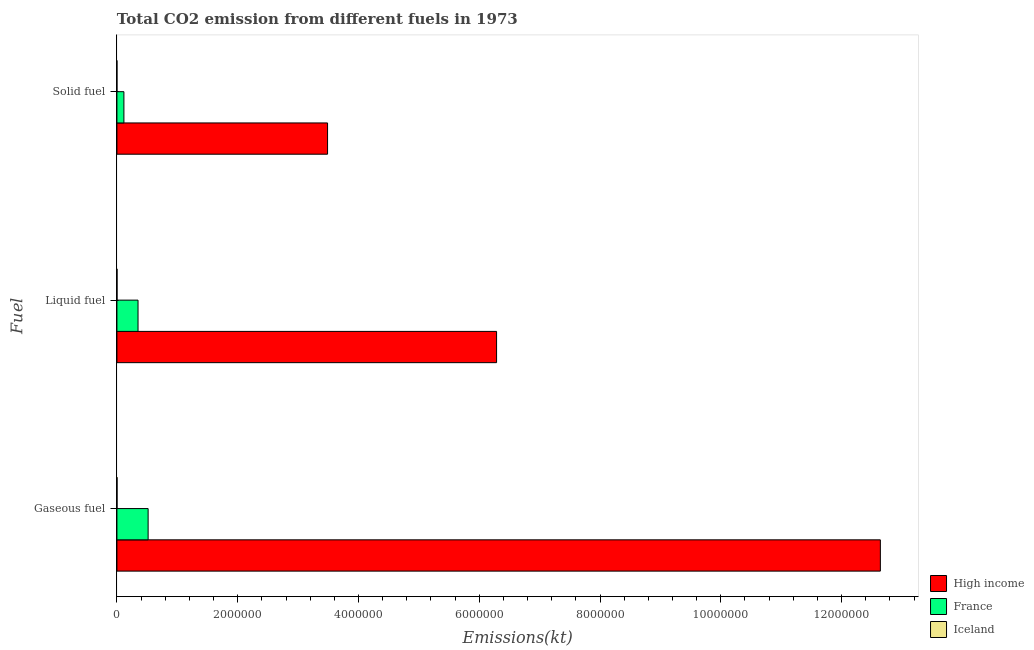How many groups of bars are there?
Offer a very short reply. 3. Are the number of bars on each tick of the Y-axis equal?
Provide a succinct answer. Yes. How many bars are there on the 2nd tick from the bottom?
Ensure brevity in your answer.  3. What is the label of the 3rd group of bars from the top?
Give a very brief answer. Gaseous fuel. What is the amount of co2 emissions from gaseous fuel in High income?
Provide a succinct answer. 1.26e+07. Across all countries, what is the maximum amount of co2 emissions from liquid fuel?
Provide a succinct answer. 6.29e+06. Across all countries, what is the minimum amount of co2 emissions from gaseous fuel?
Ensure brevity in your answer.  1752.83. What is the total amount of co2 emissions from gaseous fuel in the graph?
Your answer should be compact. 1.32e+07. What is the difference between the amount of co2 emissions from gaseous fuel in Iceland and that in France?
Your answer should be compact. -5.15e+05. What is the difference between the amount of co2 emissions from gaseous fuel in France and the amount of co2 emissions from liquid fuel in Iceland?
Your answer should be compact. 5.15e+05. What is the average amount of co2 emissions from liquid fuel per country?
Ensure brevity in your answer.  2.21e+06. What is the difference between the amount of co2 emissions from liquid fuel and amount of co2 emissions from solid fuel in Iceland?
Your answer should be compact. 1683.15. In how many countries, is the amount of co2 emissions from gaseous fuel greater than 1600000 kt?
Keep it short and to the point. 1. What is the ratio of the amount of co2 emissions from gaseous fuel in France to that in Iceland?
Keep it short and to the point. 294.72. What is the difference between the highest and the second highest amount of co2 emissions from gaseous fuel?
Give a very brief answer. 1.21e+07. What is the difference between the highest and the lowest amount of co2 emissions from solid fuel?
Give a very brief answer. 3.49e+06. In how many countries, is the amount of co2 emissions from gaseous fuel greater than the average amount of co2 emissions from gaseous fuel taken over all countries?
Make the answer very short. 1. Is it the case that in every country, the sum of the amount of co2 emissions from gaseous fuel and amount of co2 emissions from liquid fuel is greater than the amount of co2 emissions from solid fuel?
Give a very brief answer. Yes. Where does the legend appear in the graph?
Provide a succinct answer. Bottom right. How are the legend labels stacked?
Offer a very short reply. Vertical. What is the title of the graph?
Your response must be concise. Total CO2 emission from different fuels in 1973. Does "Afghanistan" appear as one of the legend labels in the graph?
Keep it short and to the point. No. What is the label or title of the X-axis?
Ensure brevity in your answer.  Emissions(kt). What is the label or title of the Y-axis?
Your answer should be very brief. Fuel. What is the Emissions(kt) of High income in Gaseous fuel?
Your answer should be very brief. 1.26e+07. What is the Emissions(kt) in France in Gaseous fuel?
Keep it short and to the point. 5.17e+05. What is the Emissions(kt) of Iceland in Gaseous fuel?
Offer a very short reply. 1752.83. What is the Emissions(kt) in High income in Liquid fuel?
Offer a terse response. 6.29e+06. What is the Emissions(kt) in France in Liquid fuel?
Make the answer very short. 3.49e+05. What is the Emissions(kt) in Iceland in Liquid fuel?
Ensure brevity in your answer.  1686.82. What is the Emissions(kt) in High income in Solid fuel?
Your answer should be very brief. 3.49e+06. What is the Emissions(kt) in France in Solid fuel?
Offer a very short reply. 1.16e+05. What is the Emissions(kt) in Iceland in Solid fuel?
Your answer should be compact. 3.67. Across all Fuel, what is the maximum Emissions(kt) in High income?
Provide a short and direct response. 1.26e+07. Across all Fuel, what is the maximum Emissions(kt) of France?
Ensure brevity in your answer.  5.17e+05. Across all Fuel, what is the maximum Emissions(kt) in Iceland?
Offer a terse response. 1752.83. Across all Fuel, what is the minimum Emissions(kt) of High income?
Provide a succinct answer. 3.49e+06. Across all Fuel, what is the minimum Emissions(kt) in France?
Give a very brief answer. 1.16e+05. Across all Fuel, what is the minimum Emissions(kt) in Iceland?
Offer a terse response. 3.67. What is the total Emissions(kt) of High income in the graph?
Provide a succinct answer. 2.24e+07. What is the total Emissions(kt) of France in the graph?
Offer a terse response. 9.82e+05. What is the total Emissions(kt) of Iceland in the graph?
Offer a terse response. 3443.31. What is the difference between the Emissions(kt) of High income in Gaseous fuel and that in Liquid fuel?
Your answer should be compact. 6.35e+06. What is the difference between the Emissions(kt) in France in Gaseous fuel and that in Liquid fuel?
Offer a terse response. 1.67e+05. What is the difference between the Emissions(kt) of Iceland in Gaseous fuel and that in Liquid fuel?
Ensure brevity in your answer.  66.01. What is the difference between the Emissions(kt) of High income in Gaseous fuel and that in Solid fuel?
Give a very brief answer. 9.15e+06. What is the difference between the Emissions(kt) in France in Gaseous fuel and that in Solid fuel?
Provide a succinct answer. 4.01e+05. What is the difference between the Emissions(kt) in Iceland in Gaseous fuel and that in Solid fuel?
Provide a succinct answer. 1749.16. What is the difference between the Emissions(kt) in High income in Liquid fuel and that in Solid fuel?
Keep it short and to the point. 2.80e+06. What is the difference between the Emissions(kt) of France in Liquid fuel and that in Solid fuel?
Offer a very short reply. 2.34e+05. What is the difference between the Emissions(kt) of Iceland in Liquid fuel and that in Solid fuel?
Give a very brief answer. 1683.15. What is the difference between the Emissions(kt) in High income in Gaseous fuel and the Emissions(kt) in France in Liquid fuel?
Ensure brevity in your answer.  1.23e+07. What is the difference between the Emissions(kt) of High income in Gaseous fuel and the Emissions(kt) of Iceland in Liquid fuel?
Provide a short and direct response. 1.26e+07. What is the difference between the Emissions(kt) of France in Gaseous fuel and the Emissions(kt) of Iceland in Liquid fuel?
Your answer should be compact. 5.15e+05. What is the difference between the Emissions(kt) of High income in Gaseous fuel and the Emissions(kt) of France in Solid fuel?
Keep it short and to the point. 1.25e+07. What is the difference between the Emissions(kt) of High income in Gaseous fuel and the Emissions(kt) of Iceland in Solid fuel?
Offer a terse response. 1.26e+07. What is the difference between the Emissions(kt) of France in Gaseous fuel and the Emissions(kt) of Iceland in Solid fuel?
Keep it short and to the point. 5.17e+05. What is the difference between the Emissions(kt) of High income in Liquid fuel and the Emissions(kt) of France in Solid fuel?
Ensure brevity in your answer.  6.17e+06. What is the difference between the Emissions(kt) in High income in Liquid fuel and the Emissions(kt) in Iceland in Solid fuel?
Your answer should be compact. 6.29e+06. What is the difference between the Emissions(kt) of France in Liquid fuel and the Emissions(kt) of Iceland in Solid fuel?
Provide a short and direct response. 3.49e+05. What is the average Emissions(kt) of High income per Fuel?
Offer a very short reply. 7.47e+06. What is the average Emissions(kt) of France per Fuel?
Your answer should be compact. 3.27e+05. What is the average Emissions(kt) of Iceland per Fuel?
Your answer should be very brief. 1147.77. What is the difference between the Emissions(kt) in High income and Emissions(kt) in France in Gaseous fuel?
Your answer should be very brief. 1.21e+07. What is the difference between the Emissions(kt) in High income and Emissions(kt) in Iceland in Gaseous fuel?
Offer a very short reply. 1.26e+07. What is the difference between the Emissions(kt) of France and Emissions(kt) of Iceland in Gaseous fuel?
Keep it short and to the point. 5.15e+05. What is the difference between the Emissions(kt) in High income and Emissions(kt) in France in Liquid fuel?
Your answer should be very brief. 5.94e+06. What is the difference between the Emissions(kt) of High income and Emissions(kt) of Iceland in Liquid fuel?
Give a very brief answer. 6.29e+06. What is the difference between the Emissions(kt) in France and Emissions(kt) in Iceland in Liquid fuel?
Your answer should be very brief. 3.48e+05. What is the difference between the Emissions(kt) in High income and Emissions(kt) in France in Solid fuel?
Your answer should be very brief. 3.37e+06. What is the difference between the Emissions(kt) in High income and Emissions(kt) in Iceland in Solid fuel?
Make the answer very short. 3.49e+06. What is the difference between the Emissions(kt) in France and Emissions(kt) in Iceland in Solid fuel?
Give a very brief answer. 1.16e+05. What is the ratio of the Emissions(kt) of High income in Gaseous fuel to that in Liquid fuel?
Offer a terse response. 2.01. What is the ratio of the Emissions(kt) in France in Gaseous fuel to that in Liquid fuel?
Give a very brief answer. 1.48. What is the ratio of the Emissions(kt) of Iceland in Gaseous fuel to that in Liquid fuel?
Keep it short and to the point. 1.04. What is the ratio of the Emissions(kt) in High income in Gaseous fuel to that in Solid fuel?
Make the answer very short. 3.62. What is the ratio of the Emissions(kt) in France in Gaseous fuel to that in Solid fuel?
Your answer should be very brief. 4.47. What is the ratio of the Emissions(kt) in Iceland in Gaseous fuel to that in Solid fuel?
Your answer should be very brief. 478. What is the ratio of the Emissions(kt) of High income in Liquid fuel to that in Solid fuel?
Provide a succinct answer. 1.8. What is the ratio of the Emissions(kt) of France in Liquid fuel to that in Solid fuel?
Offer a very short reply. 3.02. What is the ratio of the Emissions(kt) of Iceland in Liquid fuel to that in Solid fuel?
Give a very brief answer. 460. What is the difference between the highest and the second highest Emissions(kt) in High income?
Keep it short and to the point. 6.35e+06. What is the difference between the highest and the second highest Emissions(kt) in France?
Your response must be concise. 1.67e+05. What is the difference between the highest and the second highest Emissions(kt) in Iceland?
Give a very brief answer. 66.01. What is the difference between the highest and the lowest Emissions(kt) of High income?
Your answer should be compact. 9.15e+06. What is the difference between the highest and the lowest Emissions(kt) in France?
Your response must be concise. 4.01e+05. What is the difference between the highest and the lowest Emissions(kt) in Iceland?
Provide a succinct answer. 1749.16. 